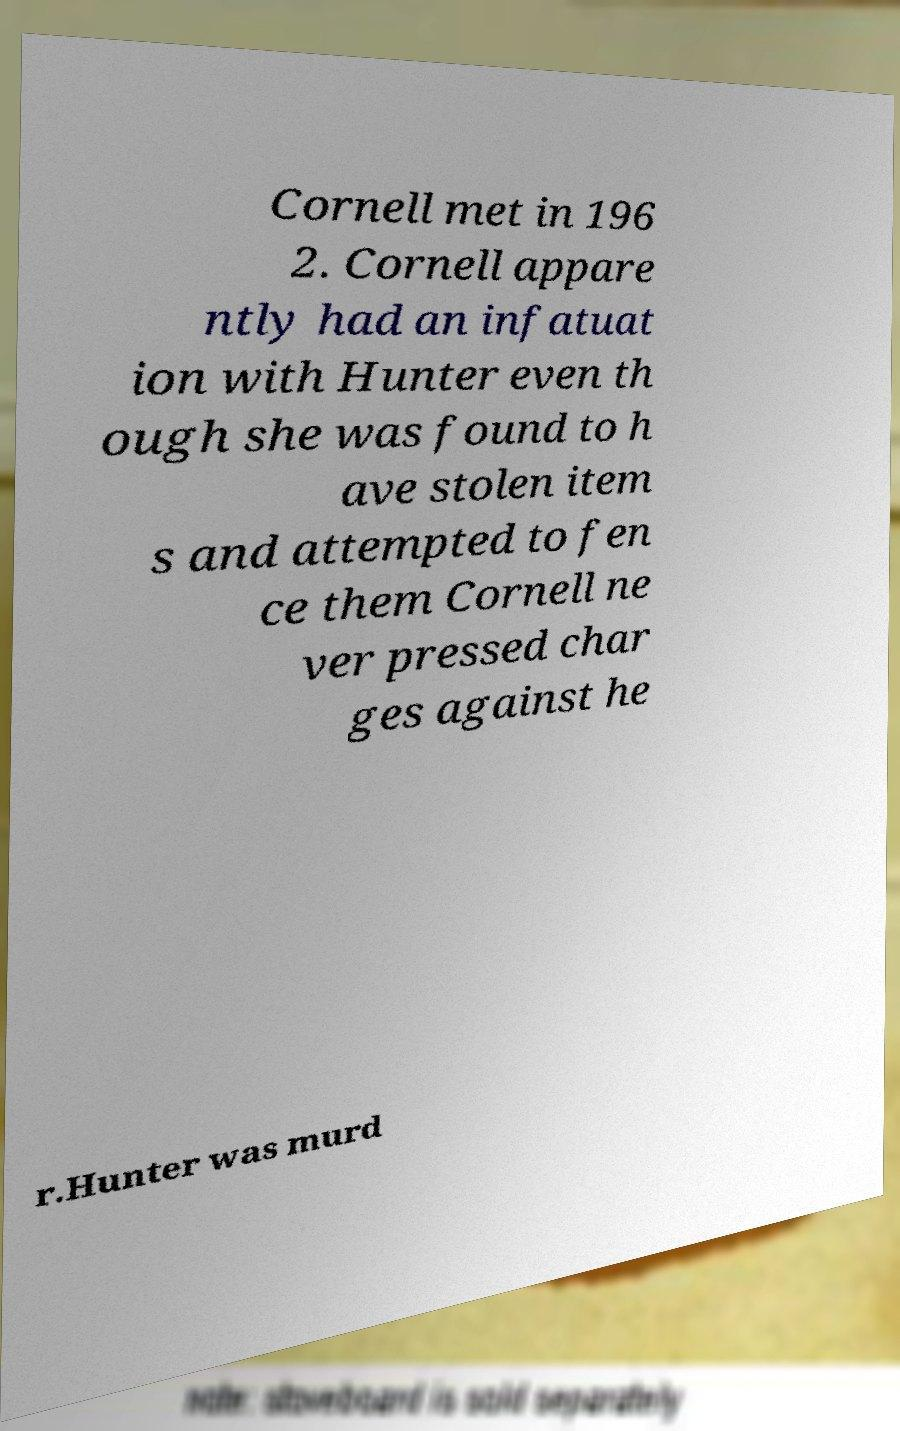Please read and relay the text visible in this image. What does it say? Cornell met in 196 2. Cornell appare ntly had an infatuat ion with Hunter even th ough she was found to h ave stolen item s and attempted to fen ce them Cornell ne ver pressed char ges against he r.Hunter was murd 